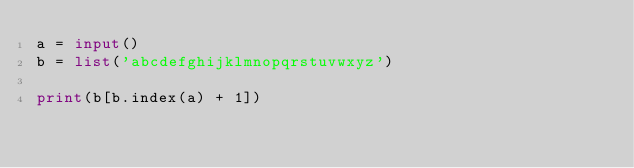Convert code to text. <code><loc_0><loc_0><loc_500><loc_500><_Python_>a = input()
b = list('abcdefghijklmnopqrstuvwxyz')

print(b[b.index(a) + 1])</code> 